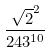<formula> <loc_0><loc_0><loc_500><loc_500>\frac { \sqrt { 2 } ^ { 2 } } { 2 4 3 ^ { 1 0 } }</formula> 